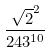<formula> <loc_0><loc_0><loc_500><loc_500>\frac { \sqrt { 2 } ^ { 2 } } { 2 4 3 ^ { 1 0 } }</formula> 